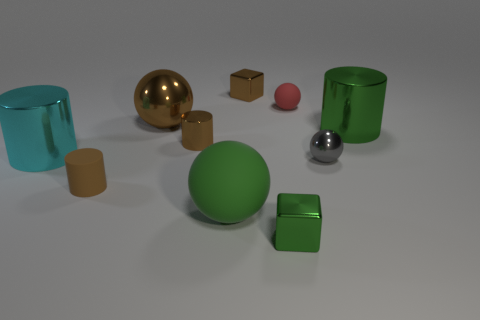Is the number of large spheres that are in front of the tiny green object less than the number of big brown shiny objects that are left of the small brown shiny cube?
Ensure brevity in your answer.  Yes. There is a cyan shiny object; what shape is it?
Provide a short and direct response. Cylinder. What is the material of the big sphere behind the cyan metal cylinder?
Your answer should be compact. Metal. There is a block behind the metal object that is in front of the small matte thing that is in front of the cyan thing; what is its size?
Your answer should be compact. Small. Does the tiny brown cylinder that is left of the big brown shiny thing have the same material as the cube that is in front of the tiny shiny ball?
Provide a short and direct response. No. How many other objects are there of the same color as the small shiny sphere?
Ensure brevity in your answer.  0. What number of objects are tiny matte objects to the right of the brown cube or small red rubber objects in front of the small brown block?
Give a very brief answer. 1. There is a metal cube that is in front of the small matte object behind the brown rubber cylinder; what size is it?
Provide a short and direct response. Small. The red rubber ball is what size?
Ensure brevity in your answer.  Small. Does the big cylinder on the right side of the small green metallic thing have the same color as the cube that is in front of the red matte sphere?
Provide a succinct answer. Yes. 